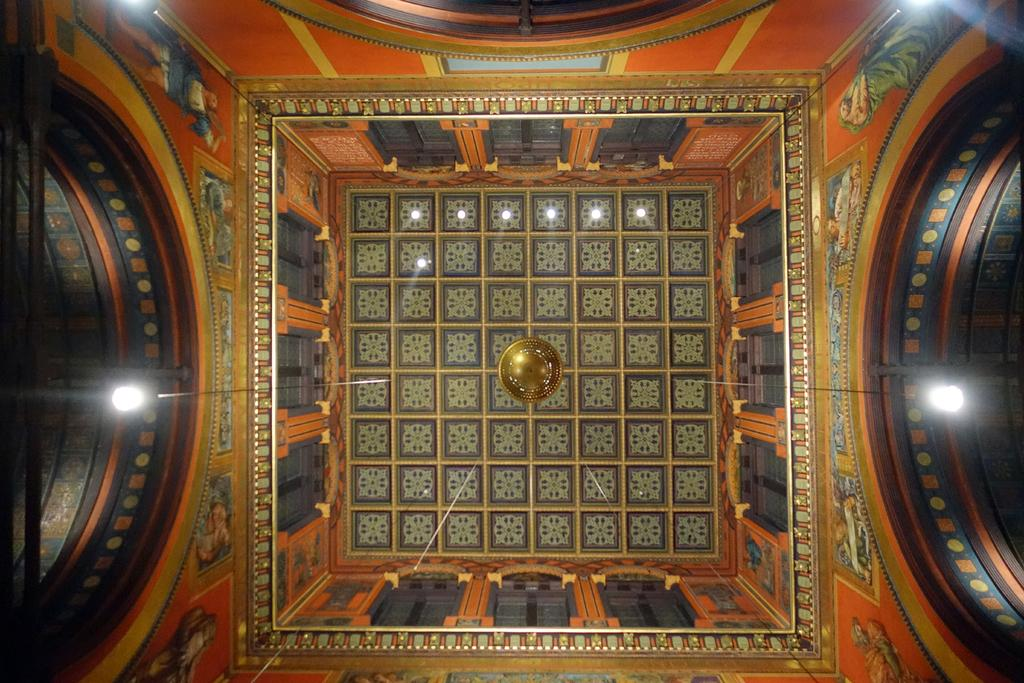What part of a building is visible in the image? The image shows the ceiling of a building. How would you describe the appearance of the ceiling? The ceiling has a designer appearance. What can be seen hanging from the ceiling? There are lights hanging from the ceiling. What type of ice can be seen melting on the ceiling in the image? There is no ice present in the image; it shows the ceiling of a building with lights hanging from it. 